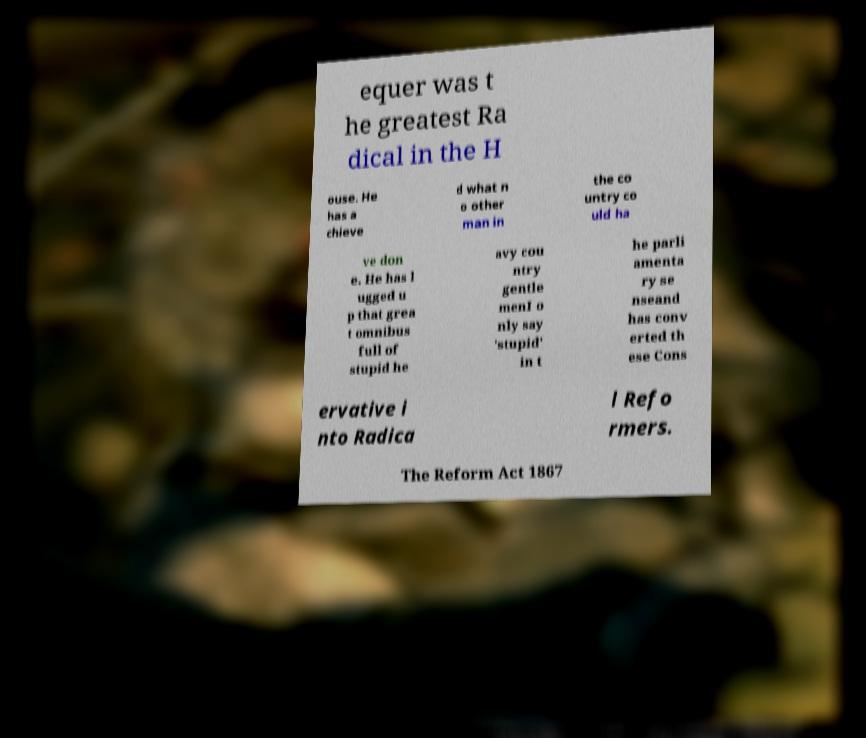What messages or text are displayed in this image? I need them in a readable, typed format. equer was t he greatest Ra dical in the H ouse. He has a chieve d what n o other man in the co untry co uld ha ve don e. He has l ugged u p that grea t omnibus full of stupid he avy cou ntry gentle menI o nly say 'stupid' in t he parli amenta ry se nseand has conv erted th ese Cons ervative i nto Radica l Refo rmers. The Reform Act 1867 